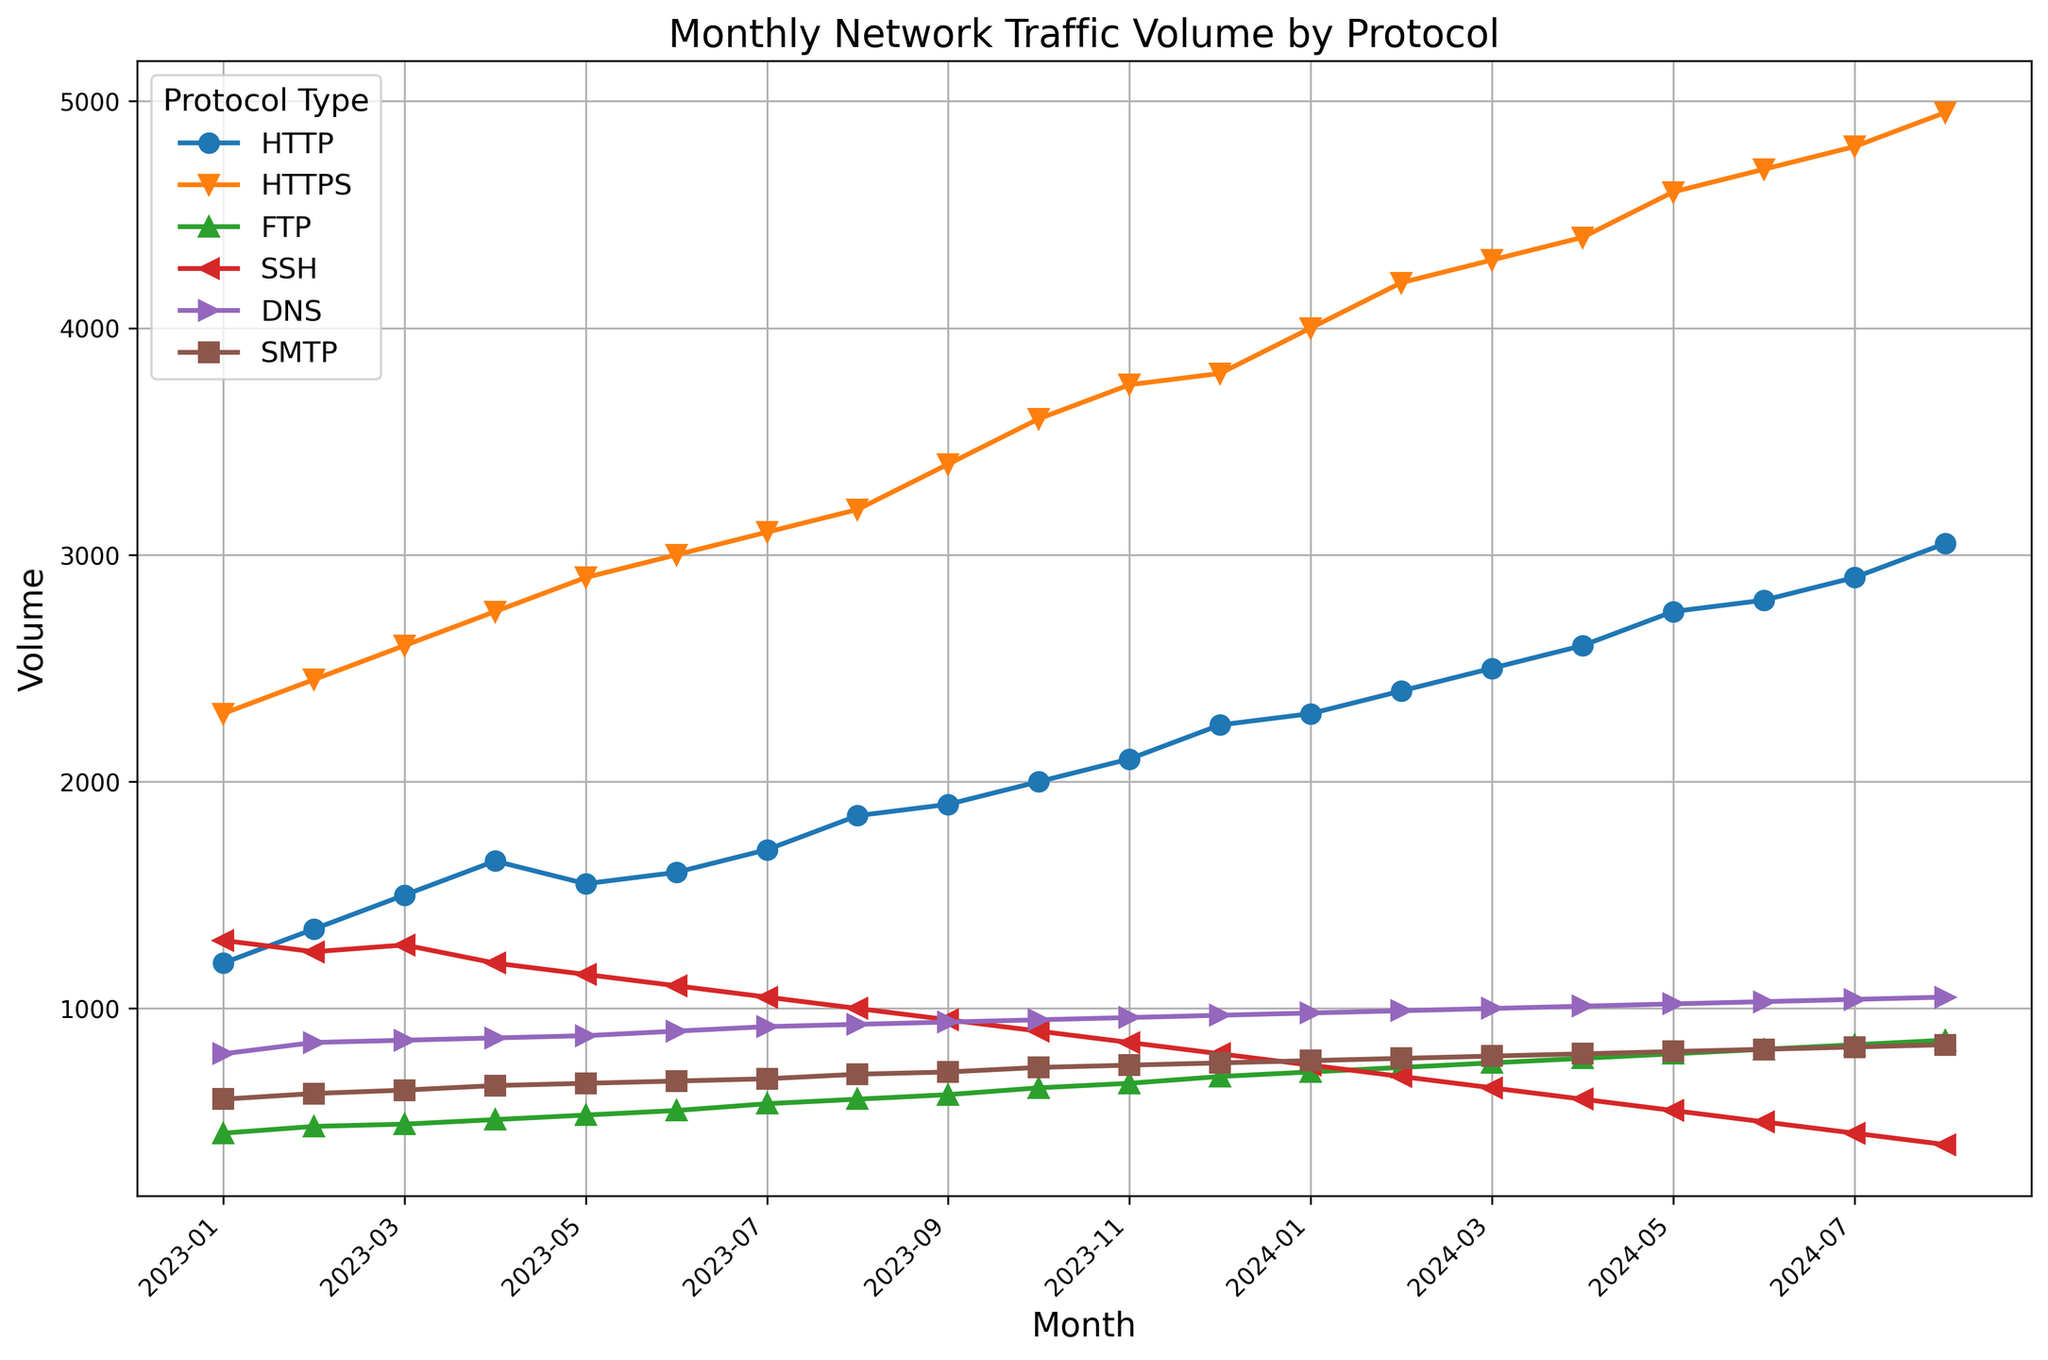What's the highest traffic volume recorded for HTTPS? Look at the HTTPS line in the figure and find the highest data point, which corresponds to the peak value.
Answer: 4950 Which protocol consistently shows the lowest traffic volume over the months? Compare the lines for each protocol and determine which one remains lower than the others through all months.
Answer: FTP How much did HTTP traffic volume increase from January 2023 to August 2024? Locate HTTP values for both January 2023 and August 2024, then calculate the difference (3050 - 1200).
Answer: 1850 Which month recorded the highest total traffic volume across all protocols? Add the volumes of all protocols for each month and compare the sums to find the highest.
Answer: August 2024 In which month did SSH traffic drop below 1000 for the first time? Identify the months where the SSH line drops below 1000 and find the earliest month.
Answer: August 2023 Which protocol type saw the most consistent increase in traffic volume over the observed period? Examine the lines and determine which one shows a steady upward trend without any troughs or sudden drops.
Answer: HTTPS By how much did SMTP traffic increase from January 2023 to April 2024? Locate SMTP values for both January 2023 and April 2024, then calculate the difference (800 - 600).
Answer: 200 Which two protocols appear to have the closest traffic volumes in December 2024? Compare the values of different protocols in December 2024 and find the ones with the smallest difference.
Answer: HTTPS and SMTP How many protocols have traffic volumes exceeding 3000 units in July 2024? Identify the protocols in July 2024 with values over 3000 by examining their lines.
Answer: Two (HTTPS and HTTP) What is the average DNS traffic volume over the entire duration? Sum all the DNS traffic volumes and divide by the number of months to get the average.
Answer: 915 